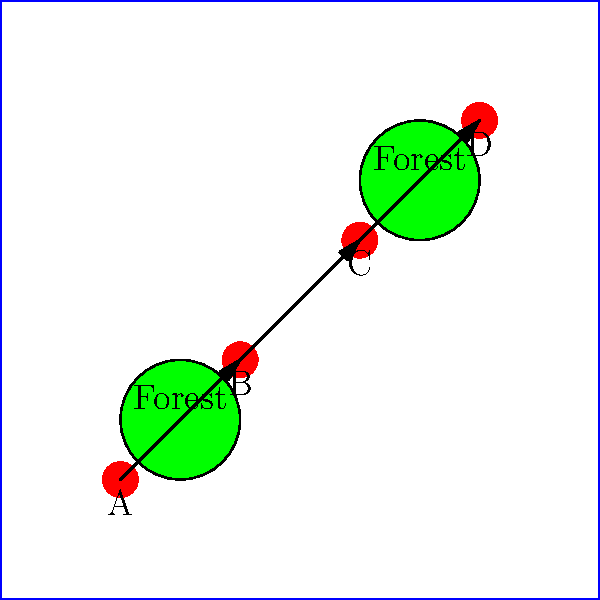Based on the tactical map shown, which unit deployment sequence would provide the most effective strategic advantage, considering the terrain and potential enemy positions? To determine the most effective strategic advantage, we need to analyze the map and consider the following factors:

1. Terrain: There are two forest areas on the map, which can provide cover and concealment.

2. Unit positions: Four units (A, B, C, and D) are positioned in a diagonal line across the map.

3. Movement arrows: The arrows suggest a potential movement pattern from A to B to C to D.

Step-by-step analysis:

1. Unit A is positioned near the first forest area, providing good initial cover.

2. Unit B is placed between the two forest areas, offering flexibility in movement.

3. Unit C is positioned near the second forest area, again providing cover.

4. Unit D is placed in the far corner, potentially serving as a flanking or reserve force.

The most effective strategic advantage would be gained by deploying the units in the following sequence:

a) Start with Unit A in the cover of the first forest.
b) Move to Unit B, which can act as a pivot point between the two forests.
c) Advance to Unit C, using the second forest for cover.
d) Finally, utilize Unit D for flanking maneuvers or as a reserve force.

This sequence allows for:
1. Maximizing cover from the forest areas
2. Maintaining flexibility in movement
3. Creating opportunities for flanking or surprise attacks
4. Establishing a strong defensive line if needed

The deployment sequence A-B-C-D provides a balance of offensive and defensive capabilities while making optimal use of the terrain.
Answer: A-B-C-D 